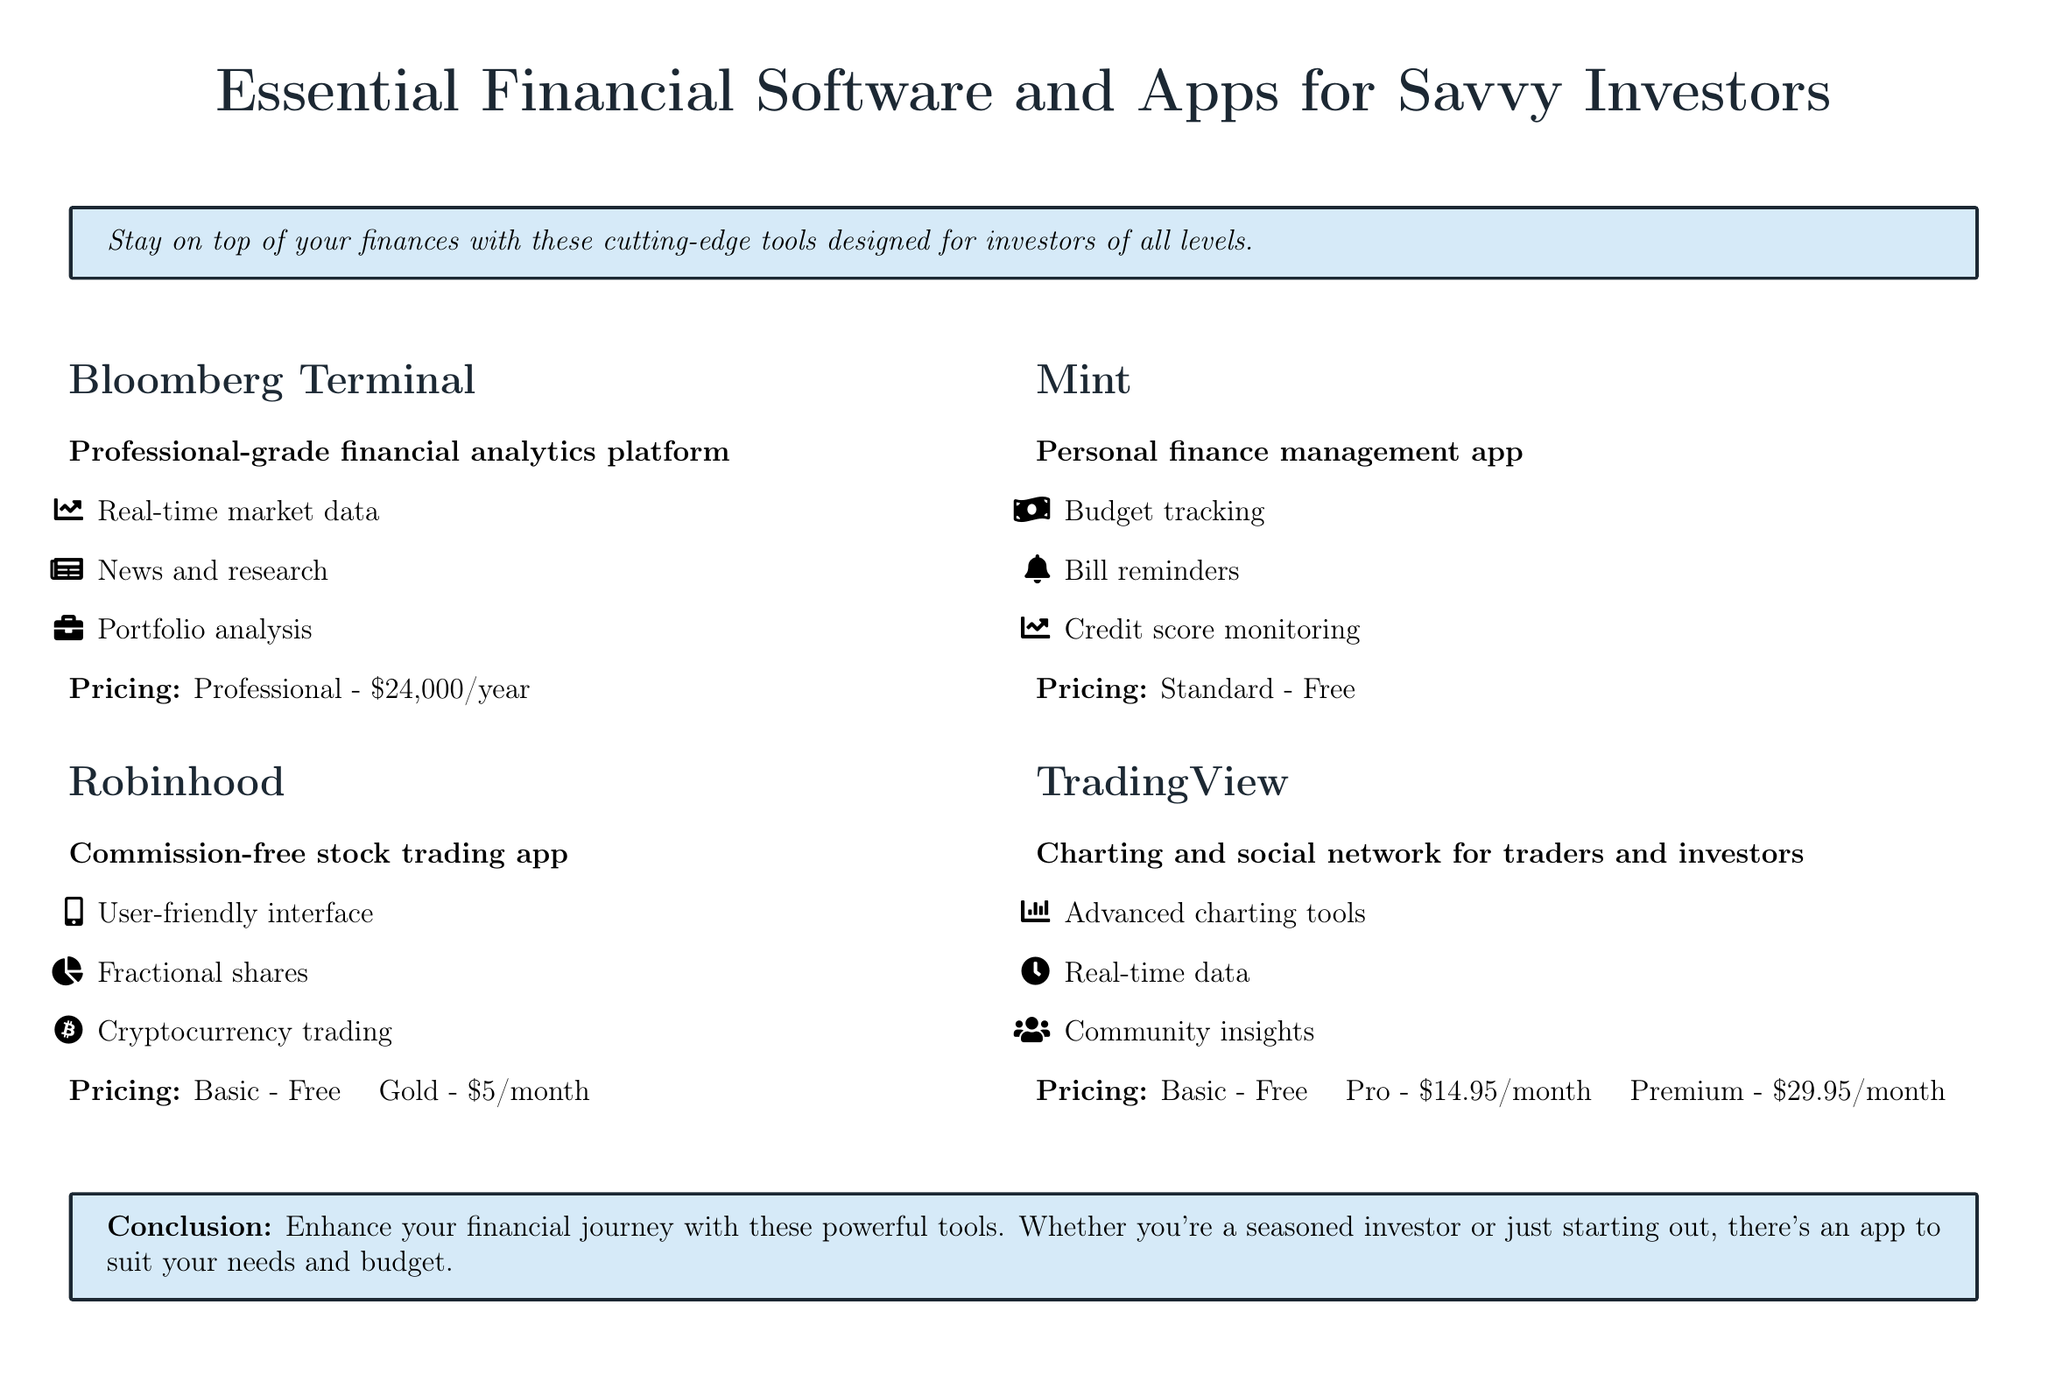What is the pricing for Bloomberg Terminal? The pricing for Bloomberg Terminal is stated in the document as $24,000/year.
Answer: $24,000/year What is the primary function of Robinhood? The document describes Robinhood as a commission-free stock trading app, highlighting its user-friendly interface and other features.
Answer: Commission-free stock trading app Which app offers credit score monitoring? The document mentions Mint as a personal finance management app that includes credit score monitoring among its features.
Answer: Mint How much does the Pro version of TradingView cost? The cost for the Pro version of TradingView is highlighted in the document as $14.95/month.
Answer: $14.95/month What feature is unique to Bloomberg Terminal compared to the other apps? The document states that Bloomberg Terminal offers professional-grade financial analytics, which distinguishes it from the other products listed.
Answer: Professional-grade financial analytics What is the pricing for Mint? In the document, Mint is listed as having a Standard pricing tier that is free.
Answer: Free What type of insights does TradingView provide? The document describes TradingView as providing community insights, indicating a social network aspect for traders and investors.
Answer: Community insights What is the monthly cost of Gold tier in Robinhood? The document specifies the Gold pricing tier for Robinhood as $5/month.
Answer: $5/month 